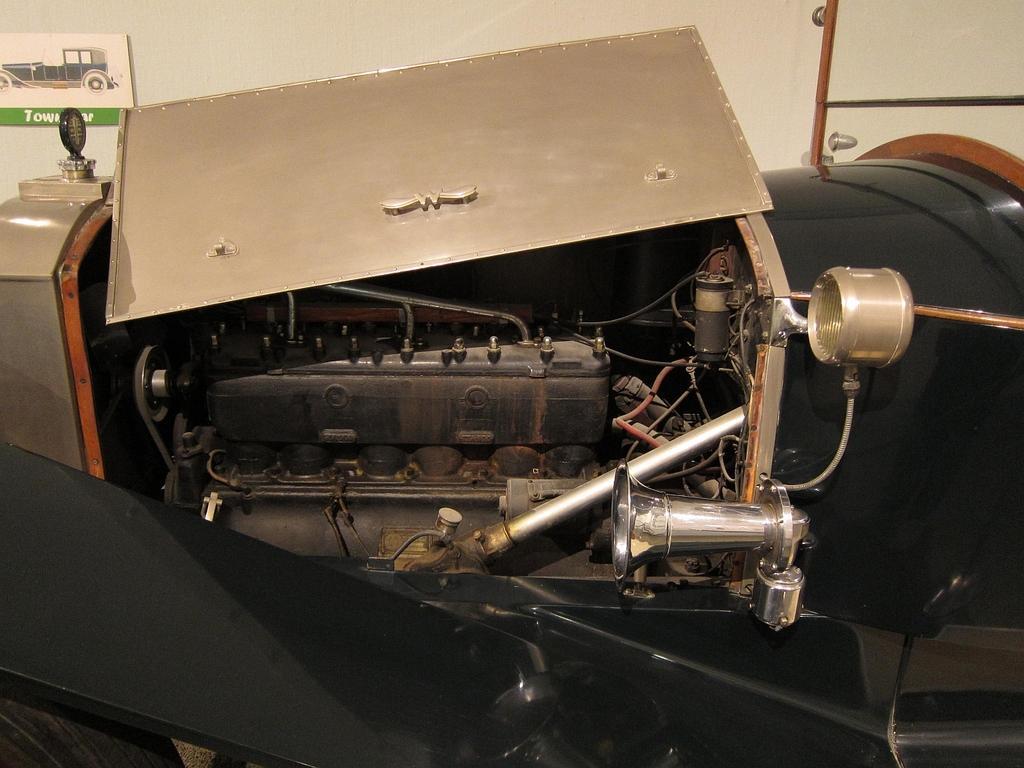In one or two sentences, can you explain what this image depicts? In the center of the image we can see an electrical equipment. In the background there is a wall. 